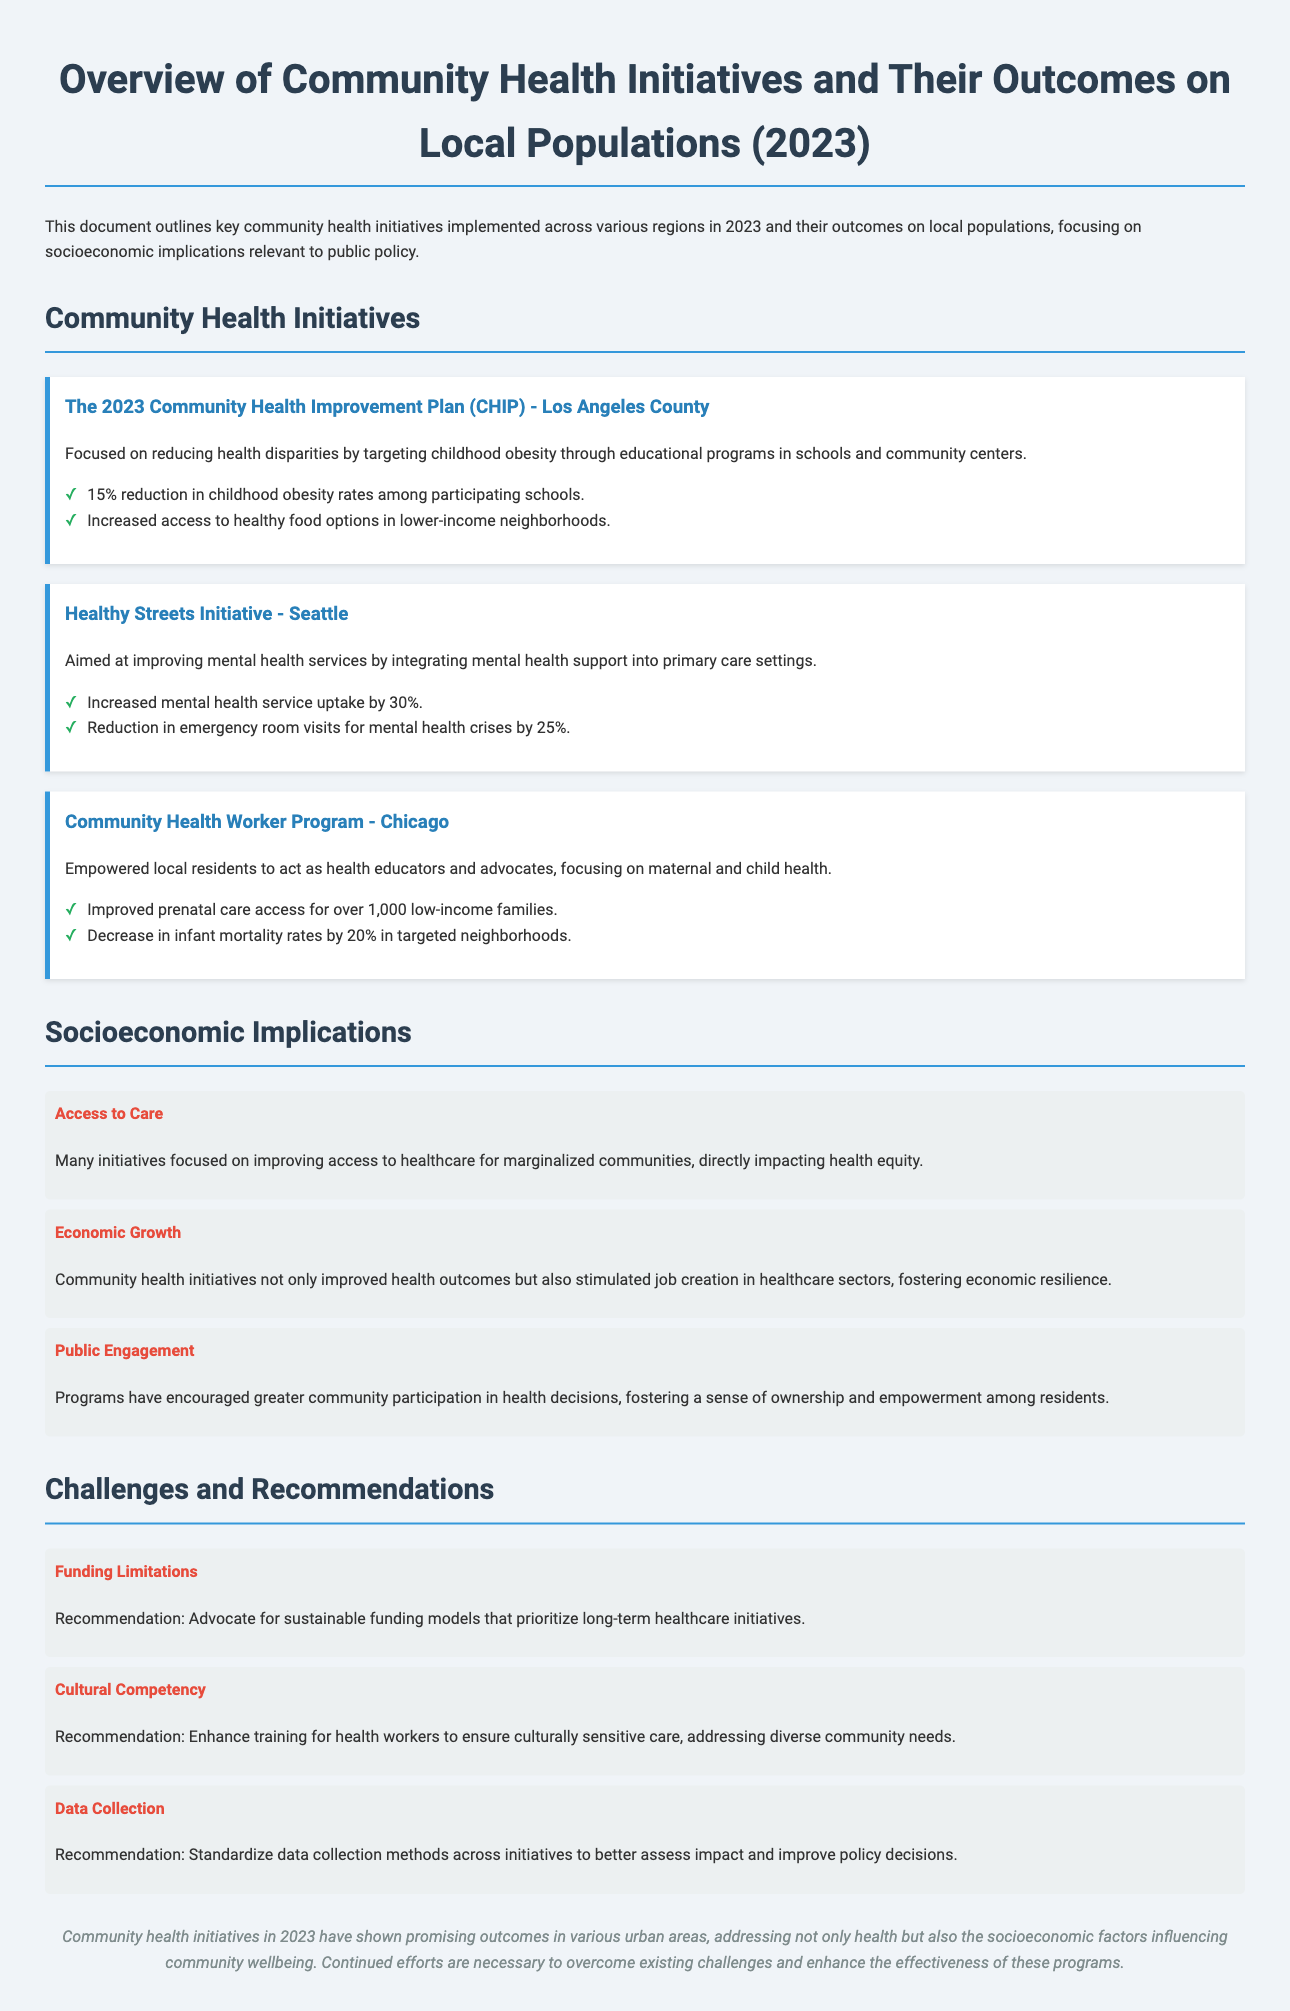what was the focus of the 2023 Community Health Improvement Plan? The focus was on reducing health disparities by targeting childhood obesity through educational programs in schools and community centers.
Answer: reducing health disparities what percentage reduction in childhood obesity rates was achieved? The document states a 15% reduction in childhood obesity rates among participating schools.
Answer: 15% what initiative aimed to improve mental health services? The initiative aimed at improving mental health services was the Healthy Streets Initiative in Seattle.
Answer: Healthy Streets Initiative how many low-income families improved access to prenatal care through the Community Health Worker Program? The Community Health Worker Program improved prenatal care access for over 1,000 low-income families.
Answer: over 1,000 what was the reduction rate of emergency room visits for mental health crises in Seattle? The document states that there was a reduction of 25% in emergency room visits for mental health crises.
Answer: 25% what socioeconomic implication focuses on improving community participation? The socioeconomic implication focusing on improving community participation is Public Engagement.
Answer: Public Engagement what is one recommendation to address funding limitations? One recommendation to address funding limitations is to advocate for sustainable funding models that prioritize long-term healthcare initiatives.
Answer: advocate for sustainable funding models what training enhancement is recommended for health workers? The recommendation is to enhance training for health workers to ensure culturally sensitive care.
Answer: enhance training for culturally sensitive care what challenge is associated with standardized data collection methods? The challenge associated is the need to standardize data collection methods across initiatives to assess impact better.
Answer: standardize data collection methods 